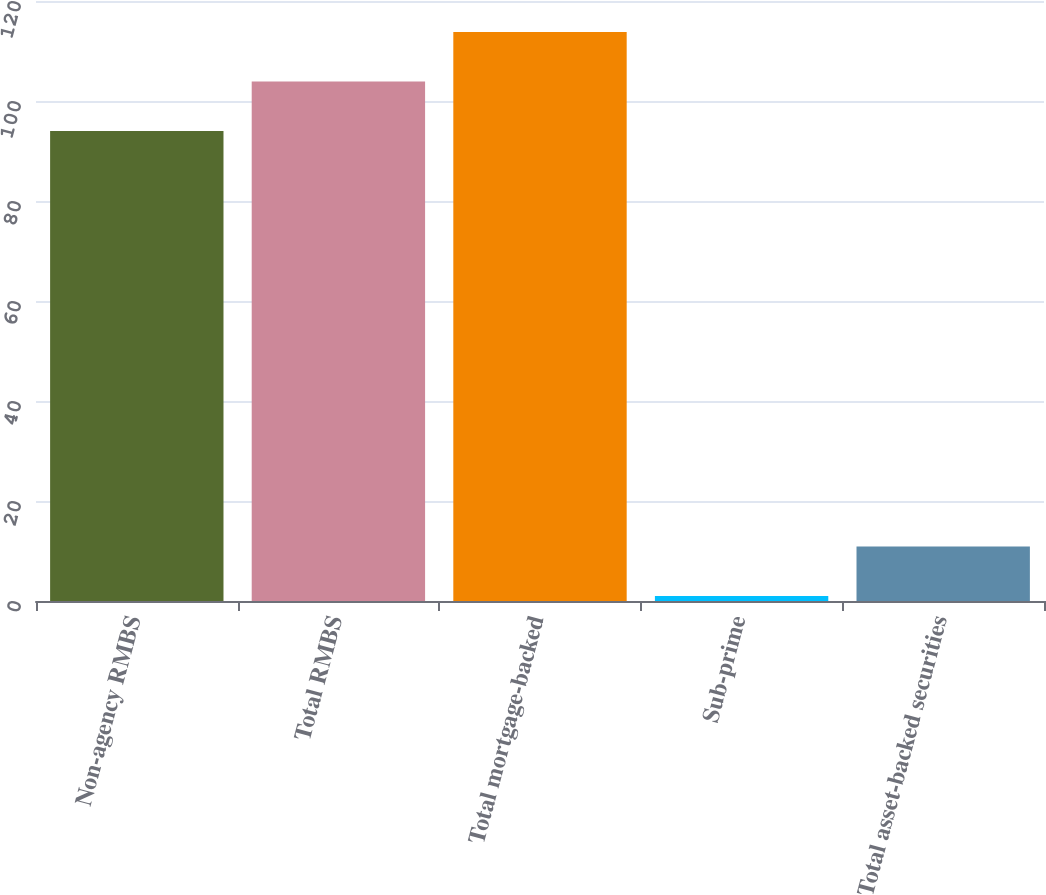Convert chart. <chart><loc_0><loc_0><loc_500><loc_500><bar_chart><fcel>Non-agency RMBS<fcel>Total RMBS<fcel>Total mortgage-backed<fcel>Sub-prime<fcel>Total asset-backed securities<nl><fcel>94<fcel>103.9<fcel>113.8<fcel>1<fcel>10.9<nl></chart> 